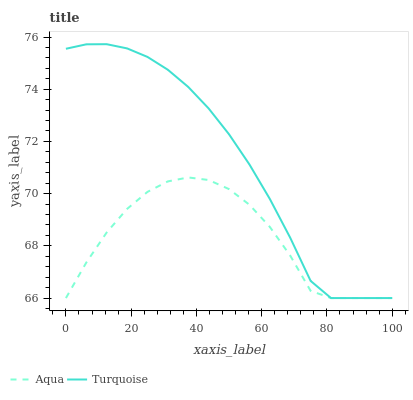Does Aqua have the minimum area under the curve?
Answer yes or no. Yes. Does Turquoise have the maximum area under the curve?
Answer yes or no. Yes. Does Aqua have the maximum area under the curve?
Answer yes or no. No. Is Turquoise the smoothest?
Answer yes or no. Yes. Is Aqua the roughest?
Answer yes or no. Yes. Is Aqua the smoothest?
Answer yes or no. No. Does Turquoise have the highest value?
Answer yes or no. Yes. Does Aqua have the highest value?
Answer yes or no. No. Does Aqua intersect Turquoise?
Answer yes or no. Yes. Is Aqua less than Turquoise?
Answer yes or no. No. Is Aqua greater than Turquoise?
Answer yes or no. No. 